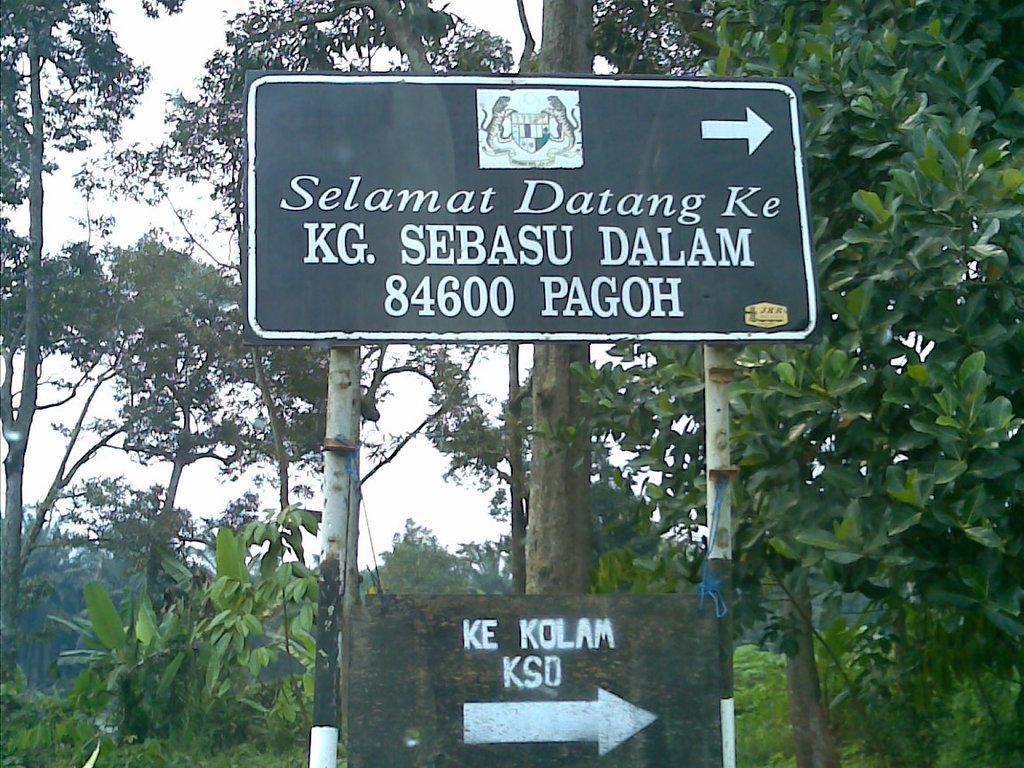What is the main object in the image? There is a direction board in the image. What can be seen in the background of the image? There are trees in the background of the image. How many crayons can be seen in the image? There are no crayons present in the image. What type of animal is visible in the image? There are no animals visible in the image; it only features a direction board and trees in the background. 